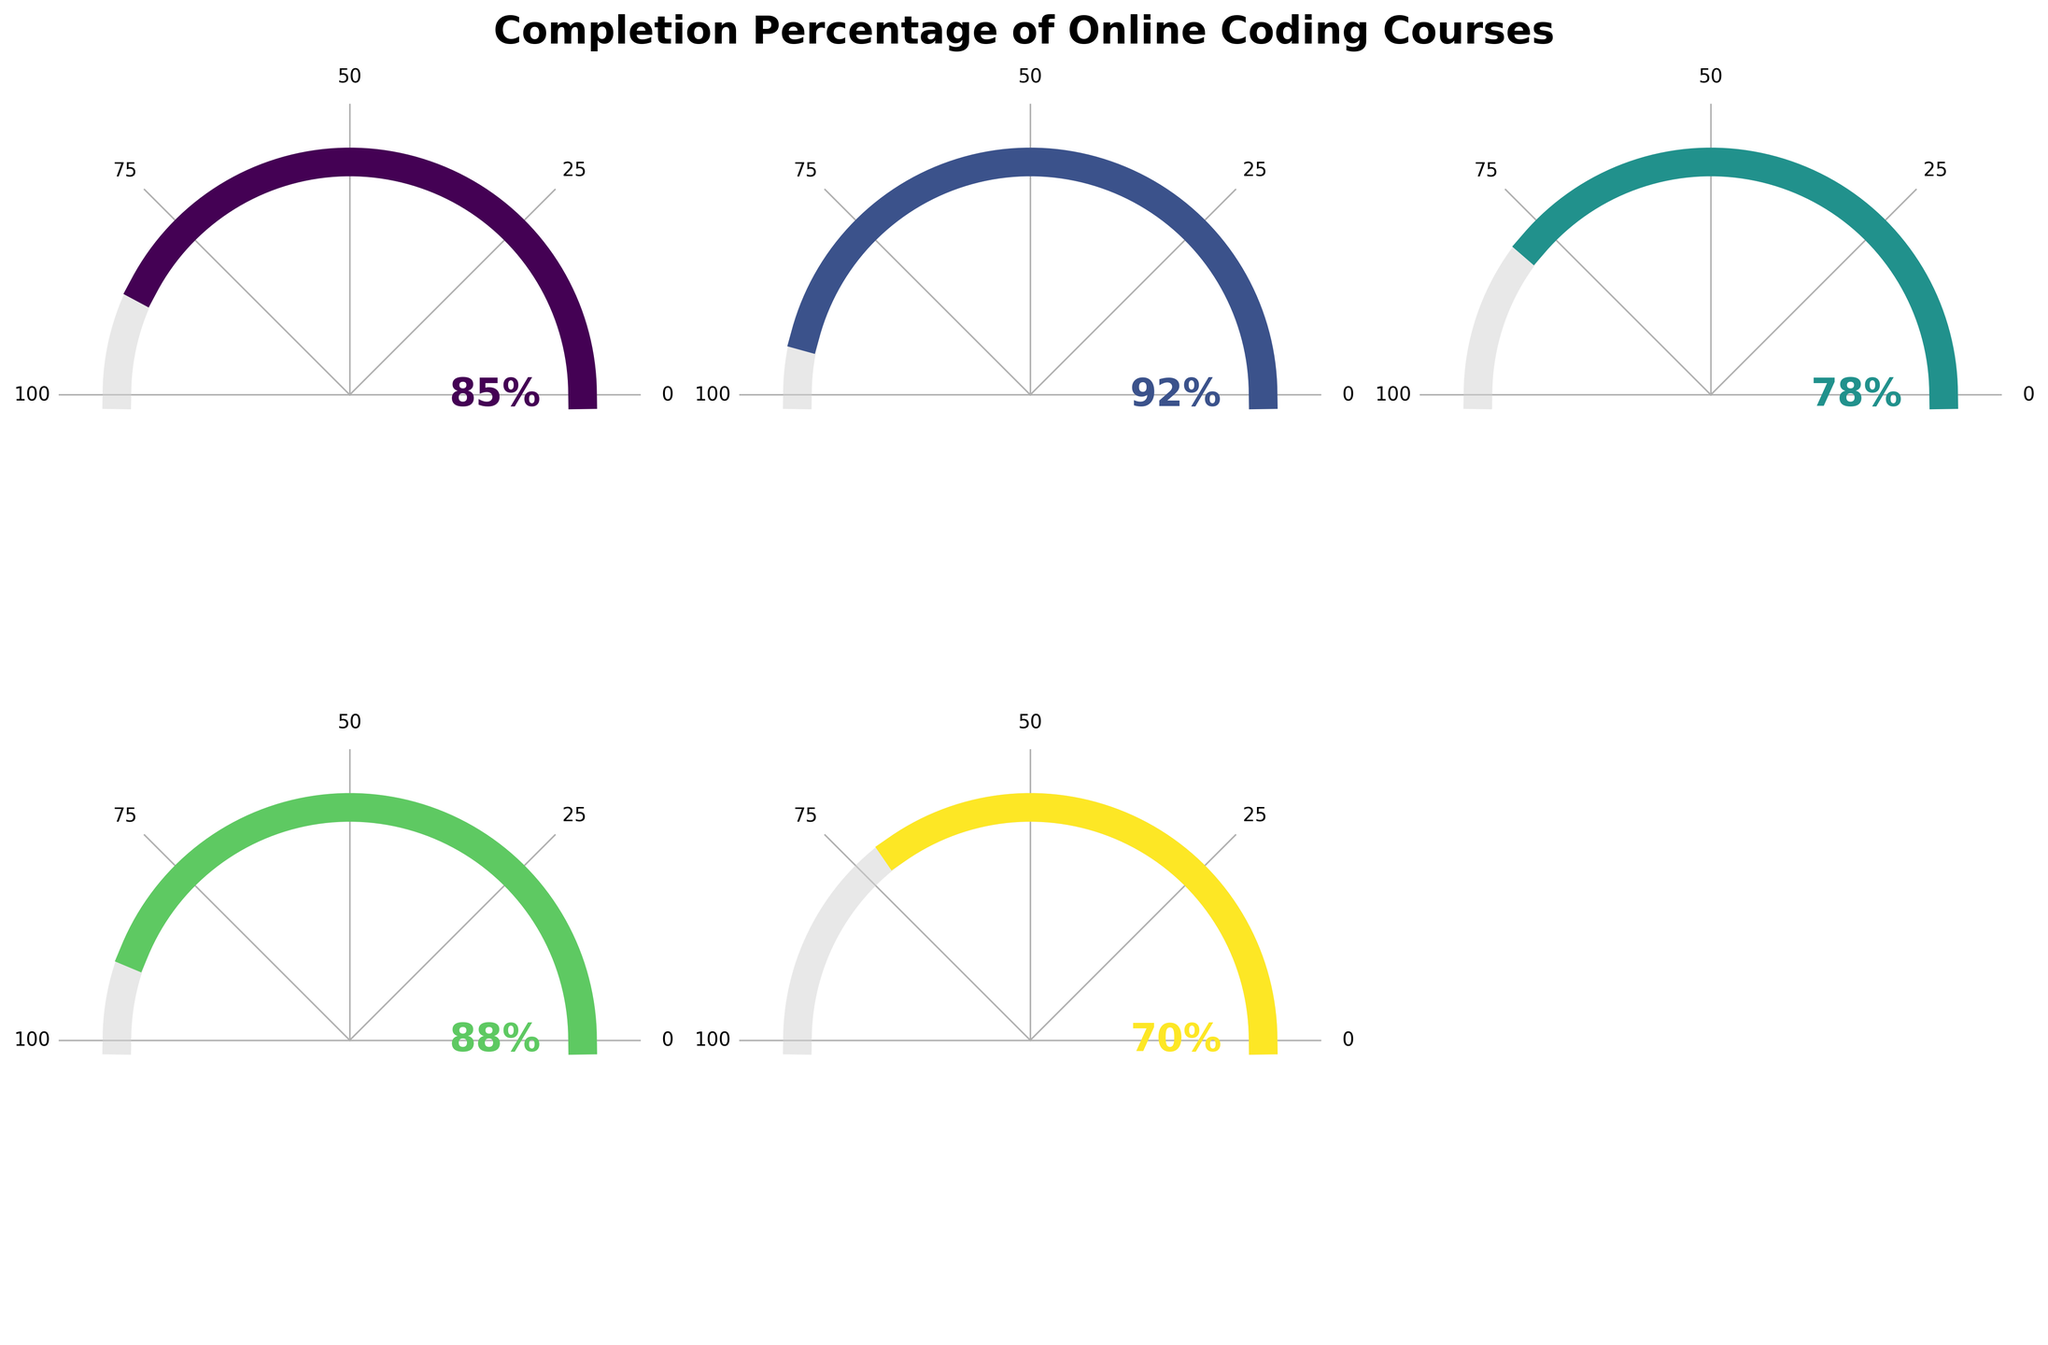How many coding courses are displayed in the figure? The figure shows five subplots of gauge charts, each representing a different online coding course.
Answer: 5 What is the completion percentage of the Udacity Full Stack Nanodegree course? The specific subplot for the Udacity Full Stack Nanodegree shows an arc filled up to 92%, indicated both by the length of the arc and a 92% label.
Answer: 92% Which course has the lowest completion percentage? By comparing the arcs and percentages on each subplot, the shortest arc and smallest percentage label belong to the Coursera Machine Learning course, showing 70%.
Answer: Coursera Machine Learning Are there any courses with a completion percentage above 90%? The subplot for the Udacity Full Stack Nanodegree shows a filled arc up to 92%, which is above 90%.
Answer: Yes, Udacity Full Stack Nanodegree What is the completion percentage range for these courses? The course completion percentages listed are 85, 92, 78, 88, and 70, with the highest being 92% (Udacity Full Stack Nanodegree) and the lowest being 70% (Coursera Machine Learning).
Answer: 70% to 92% How does the completion percentage of Codecademy Python 3 compare to FreeCodeCamp JavaScript Algorithms? Comparing the two subplots, Codecademy Python 3 shows 78%, while FreeCodeCamp JavaScript Algorithms shows 85%.
Answer: Codecademy Python 3 has a lower percentage Which two courses have the most similar completion percentages? By looking at the subplot labels and arcs, FreeCodeCamp JavaScript Algorithms (85%) and edX CS50's Web Programming (88%) have the closest percentage values.
Answer: FreeCodeCamp JavaScript Algorithms and edX CS50's Web Programming What is the average completion percentage of these courses? Sum up the percentages (85 + 92 + 78 + 88 + 70) to get 413, and divide by the number of courses (5) to get the average.
Answer: 82.6% How many courses have a completion percentage equal to or above 80%? By examining the arcs and percentage labels, the courses that meet or exceed 80% are FreeCodeCamp JavaScript Algorithms (85%), Udacity Full Stack Nanodegree (92%), and edX CS50's Web Programming (88%), making a total of three courses.
Answer: 3 